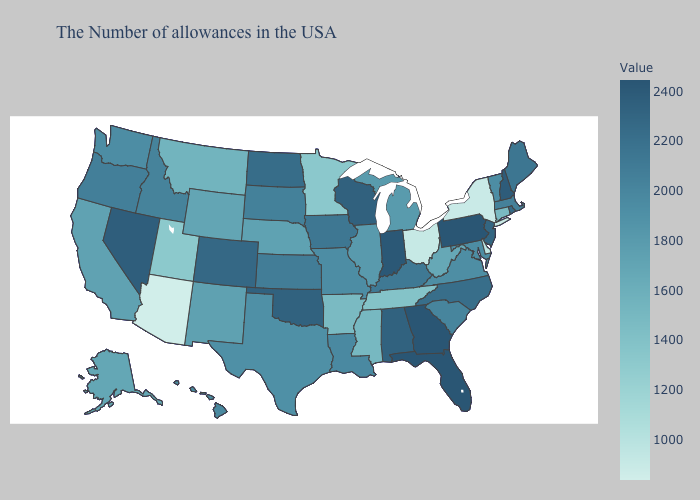Does Arkansas have a lower value than Arizona?
Quick response, please. No. Does Arizona have a higher value than Vermont?
Keep it brief. No. Among the states that border Wisconsin , which have the lowest value?
Write a very short answer. Minnesota. Does Utah have the highest value in the West?
Concise answer only. No. Among the states that border Ohio , does Michigan have the highest value?
Answer briefly. No. Which states have the lowest value in the USA?
Write a very short answer. Arizona. Does New York have a higher value than Texas?
Write a very short answer. No. Among the states that border South Carolina , does North Carolina have the lowest value?
Be succinct. Yes. 